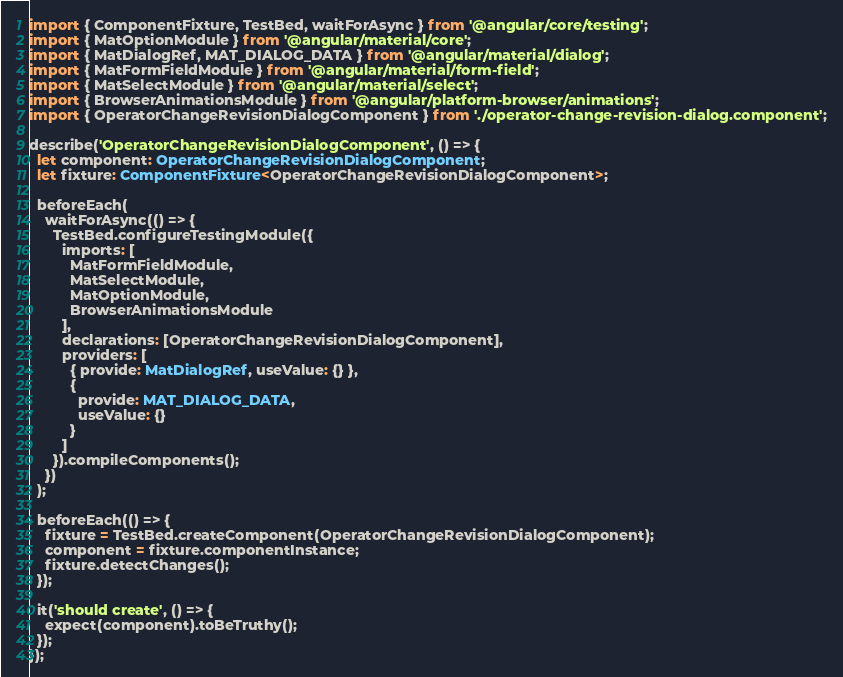Convert code to text. <code><loc_0><loc_0><loc_500><loc_500><_TypeScript_>import { ComponentFixture, TestBed, waitForAsync } from '@angular/core/testing';
import { MatOptionModule } from '@angular/material/core';
import { MatDialogRef, MAT_DIALOG_DATA } from '@angular/material/dialog';
import { MatFormFieldModule } from '@angular/material/form-field';
import { MatSelectModule } from '@angular/material/select';
import { BrowserAnimationsModule } from '@angular/platform-browser/animations';
import { OperatorChangeRevisionDialogComponent } from './operator-change-revision-dialog.component';

describe('OperatorChangeRevisionDialogComponent', () => {
  let component: OperatorChangeRevisionDialogComponent;
  let fixture: ComponentFixture<OperatorChangeRevisionDialogComponent>;

  beforeEach(
    waitForAsync(() => {
      TestBed.configureTestingModule({
        imports: [
          MatFormFieldModule,
          MatSelectModule,
          MatOptionModule,
          BrowserAnimationsModule
        ],
        declarations: [OperatorChangeRevisionDialogComponent],
        providers: [
          { provide: MatDialogRef, useValue: {} },
          {
            provide: MAT_DIALOG_DATA,
            useValue: {}
          }
        ]
      }).compileComponents();
    })
  );

  beforeEach(() => {
    fixture = TestBed.createComponent(OperatorChangeRevisionDialogComponent);
    component = fixture.componentInstance;
    fixture.detectChanges();
  });

  it('should create', () => {
    expect(component).toBeTruthy();
  });
});
</code> 